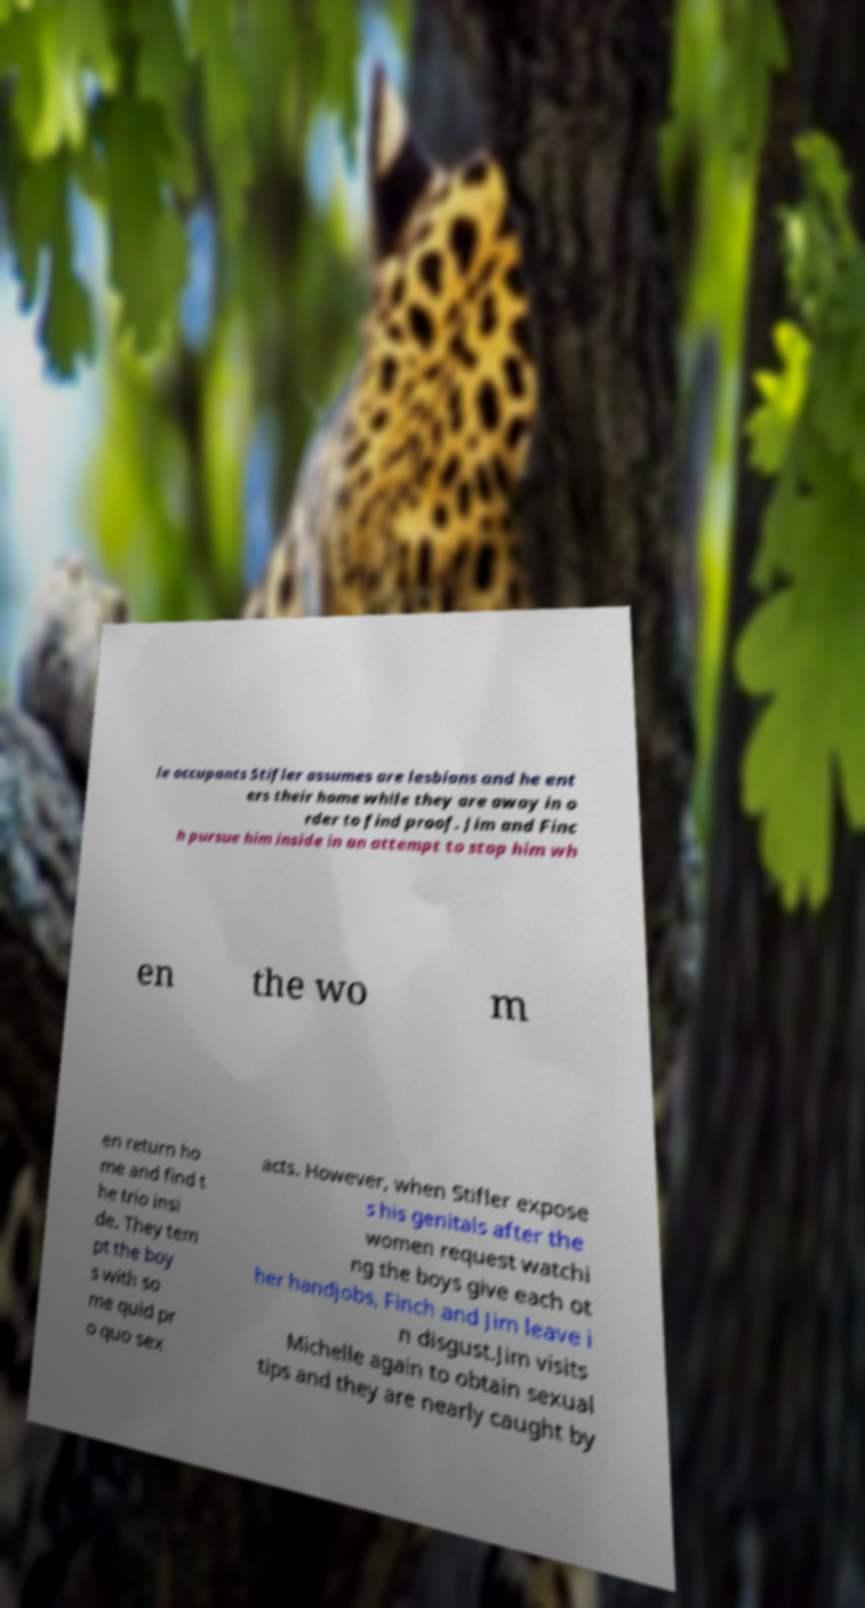Could you extract and type out the text from this image? le occupants Stifler assumes are lesbians and he ent ers their home while they are away in o rder to find proof. Jim and Finc h pursue him inside in an attempt to stop him wh en the wo m en return ho me and find t he trio insi de. They tem pt the boy s with so me quid pr o quo sex acts. However, when Stifler expose s his genitals after the women request watchi ng the boys give each ot her handjobs, Finch and Jim leave i n disgust.Jim visits Michelle again to obtain sexual tips and they are nearly caught by 